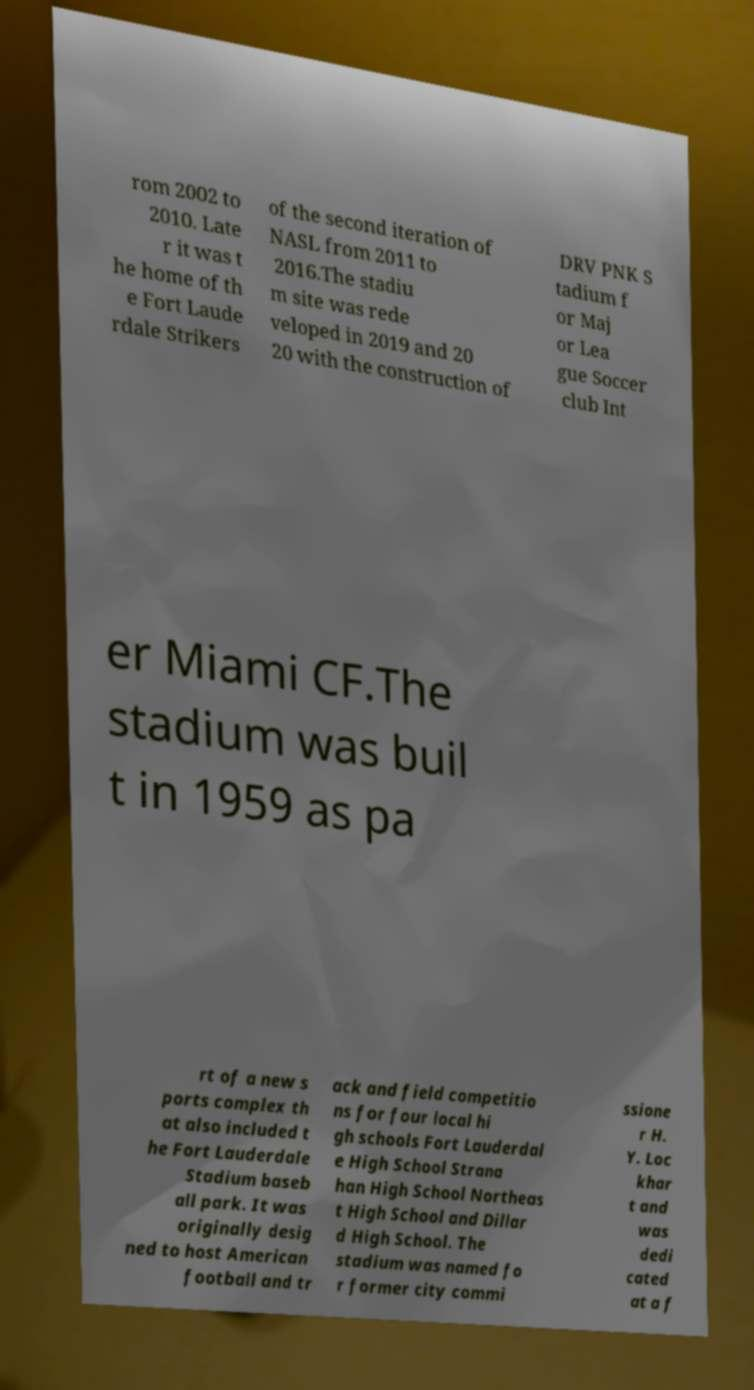Please read and relay the text visible in this image. What does it say? rom 2002 to 2010. Late r it was t he home of th e Fort Laude rdale Strikers of the second iteration of NASL from 2011 to 2016.The stadiu m site was rede veloped in 2019 and 20 20 with the construction of DRV PNK S tadium f or Maj or Lea gue Soccer club Int er Miami CF.The stadium was buil t in 1959 as pa rt of a new s ports complex th at also included t he Fort Lauderdale Stadium baseb all park. It was originally desig ned to host American football and tr ack and field competitio ns for four local hi gh schools Fort Lauderdal e High School Strana han High School Northeas t High School and Dillar d High School. The stadium was named fo r former city commi ssione r H. Y. Loc khar t and was dedi cated at a f 